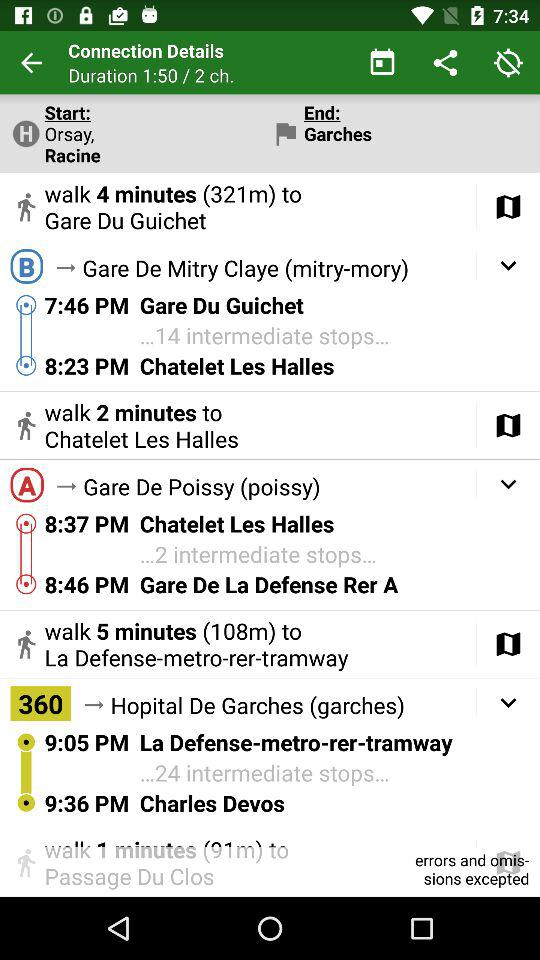How many minutes does it take to get from Charles Devos to Passage Du Clos?
Answer the question using a single word or phrase. 1 